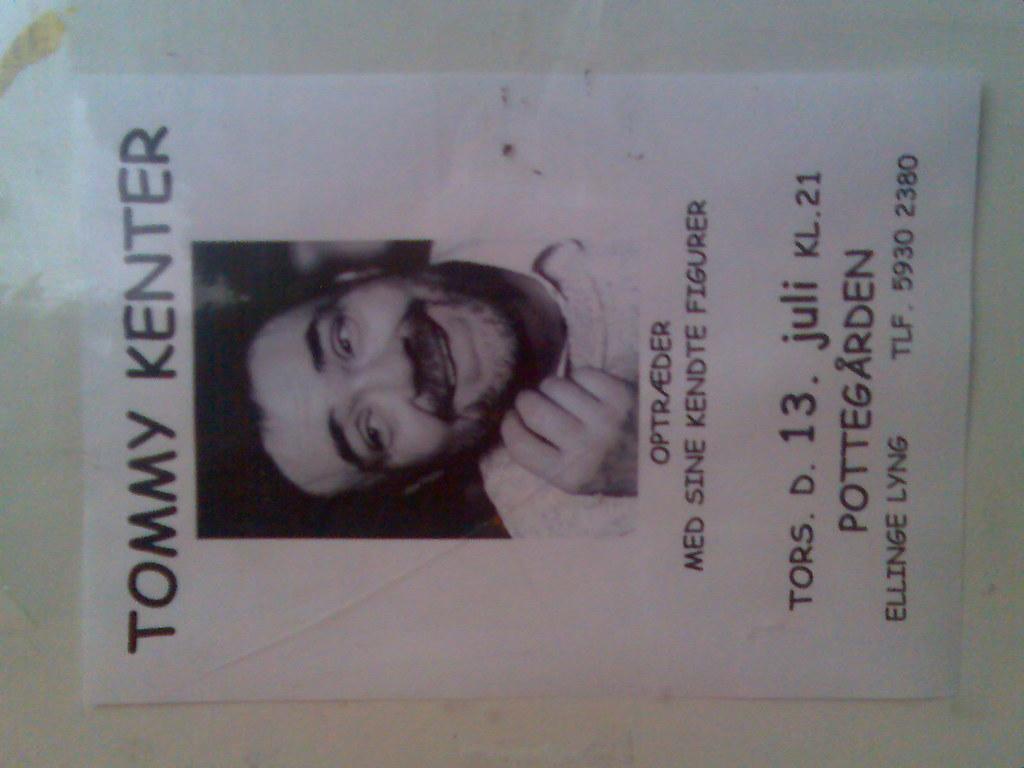Who is on the flier?
Your answer should be very brief. Tommy kenter. What telephone number is on the sign?
Ensure brevity in your answer.  5930 2380. 